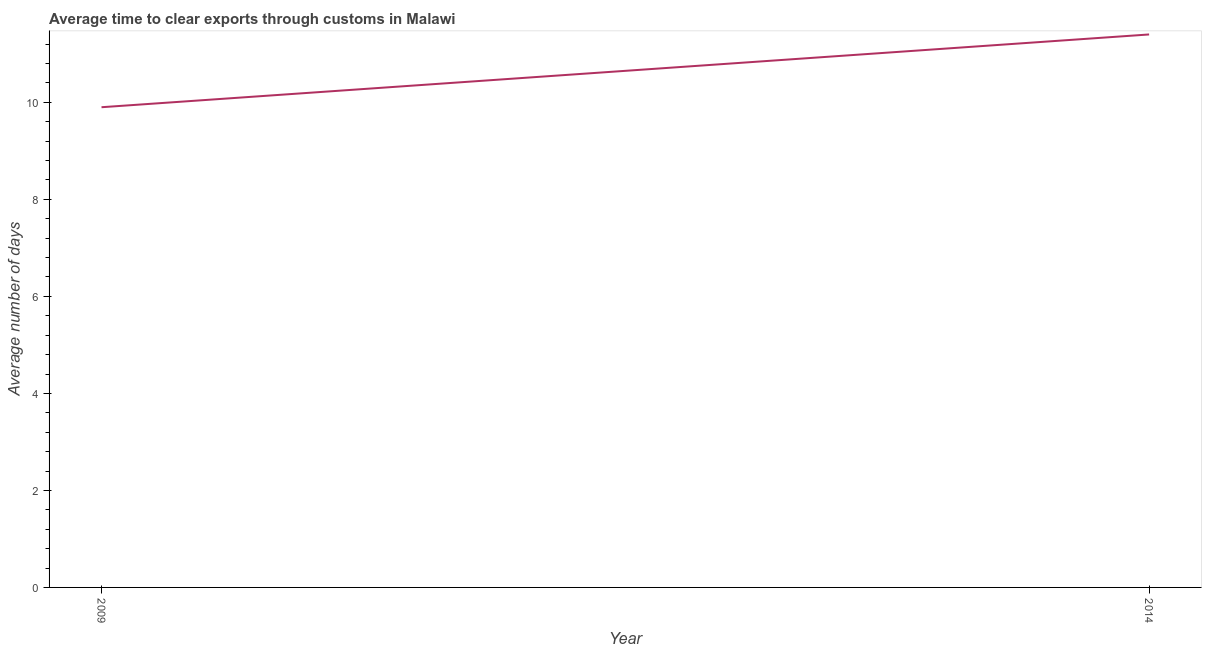What is the time to clear exports through customs in 2014?
Ensure brevity in your answer.  11.4. Across all years, what is the minimum time to clear exports through customs?
Make the answer very short. 9.9. In which year was the time to clear exports through customs minimum?
Your answer should be very brief. 2009. What is the sum of the time to clear exports through customs?
Keep it short and to the point. 21.3. What is the average time to clear exports through customs per year?
Your answer should be very brief. 10.65. What is the median time to clear exports through customs?
Your response must be concise. 10.65. What is the ratio of the time to clear exports through customs in 2009 to that in 2014?
Offer a very short reply. 0.87. Is the time to clear exports through customs in 2009 less than that in 2014?
Provide a short and direct response. Yes. In how many years, is the time to clear exports through customs greater than the average time to clear exports through customs taken over all years?
Provide a short and direct response. 1. How many years are there in the graph?
Give a very brief answer. 2. What is the title of the graph?
Your answer should be compact. Average time to clear exports through customs in Malawi. What is the label or title of the Y-axis?
Ensure brevity in your answer.  Average number of days. What is the ratio of the Average number of days in 2009 to that in 2014?
Provide a short and direct response. 0.87. 